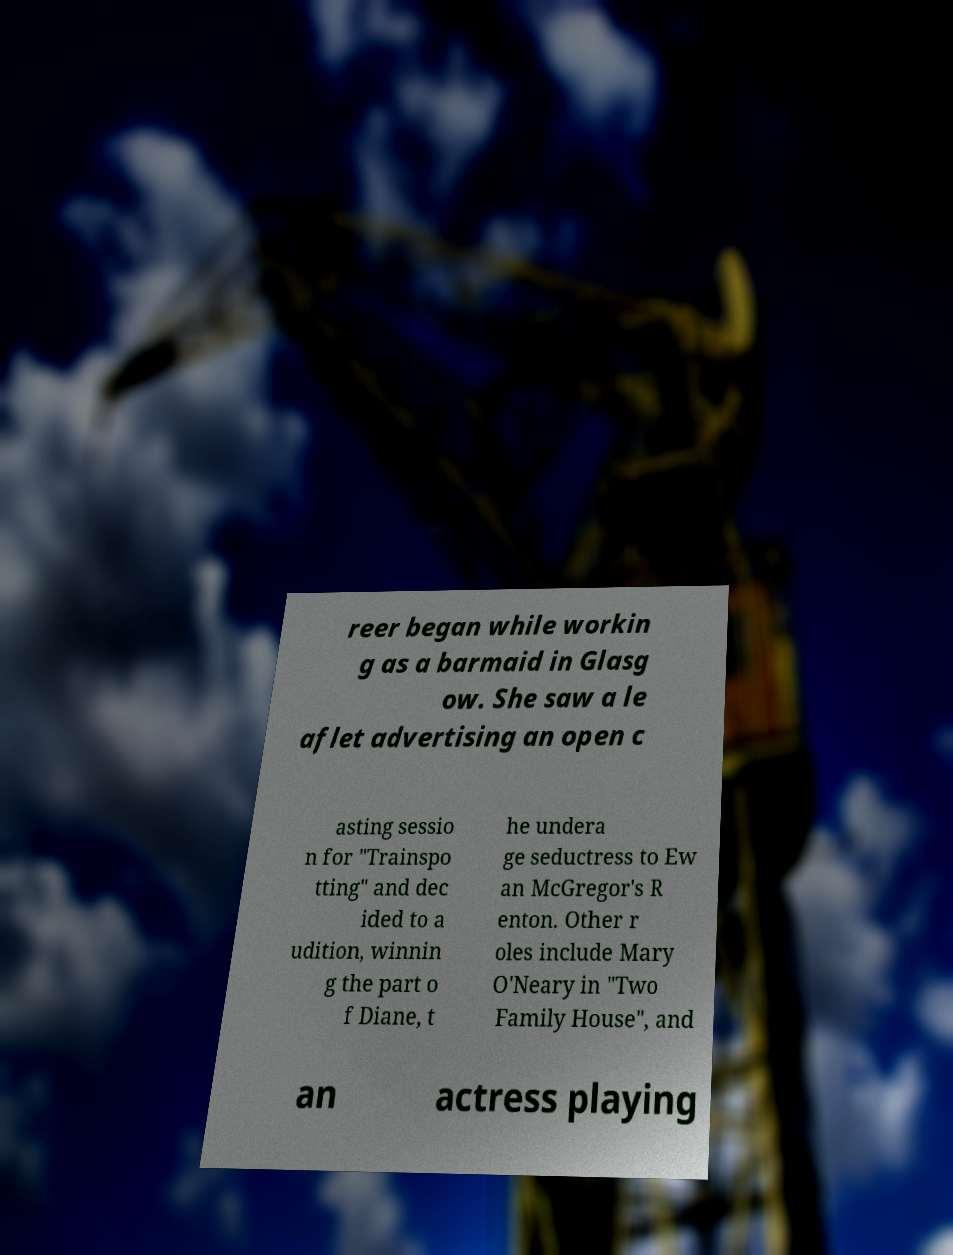Can you accurately transcribe the text from the provided image for me? reer began while workin g as a barmaid in Glasg ow. She saw a le aflet advertising an open c asting sessio n for "Trainspo tting" and dec ided to a udition, winnin g the part o f Diane, t he undera ge seductress to Ew an McGregor's R enton. Other r oles include Mary O'Neary in "Two Family House", and an actress playing 